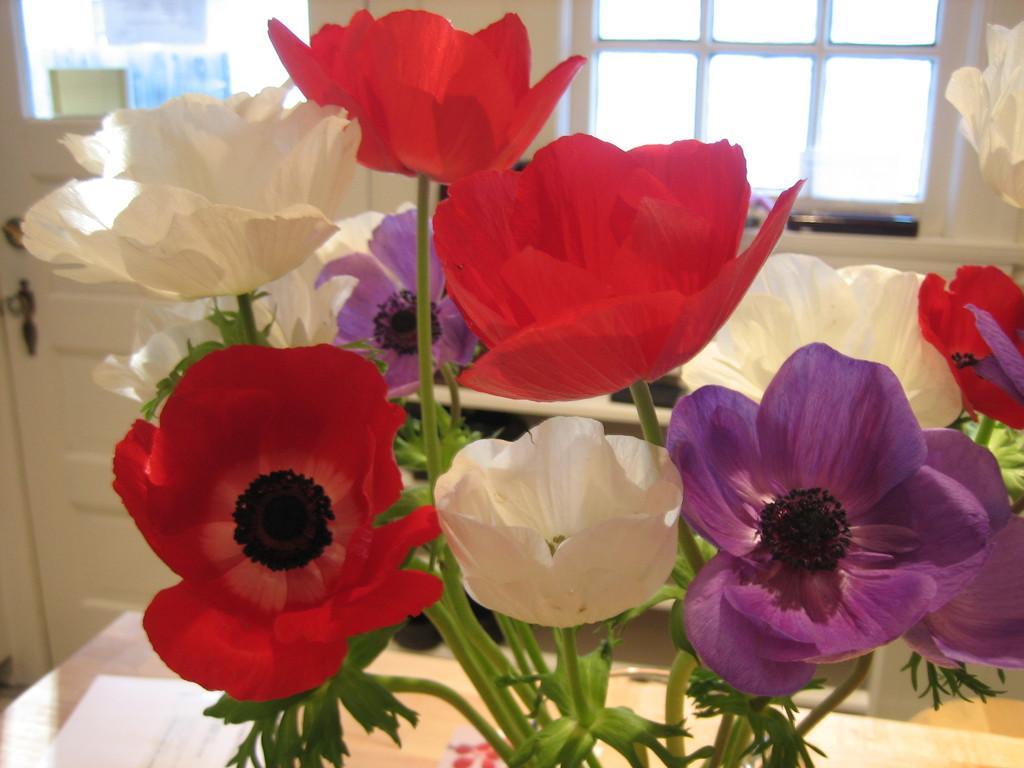Can you describe this image briefly? In this image in the front there are flowers. In the background there is a window and there is a door which are white in colour. 